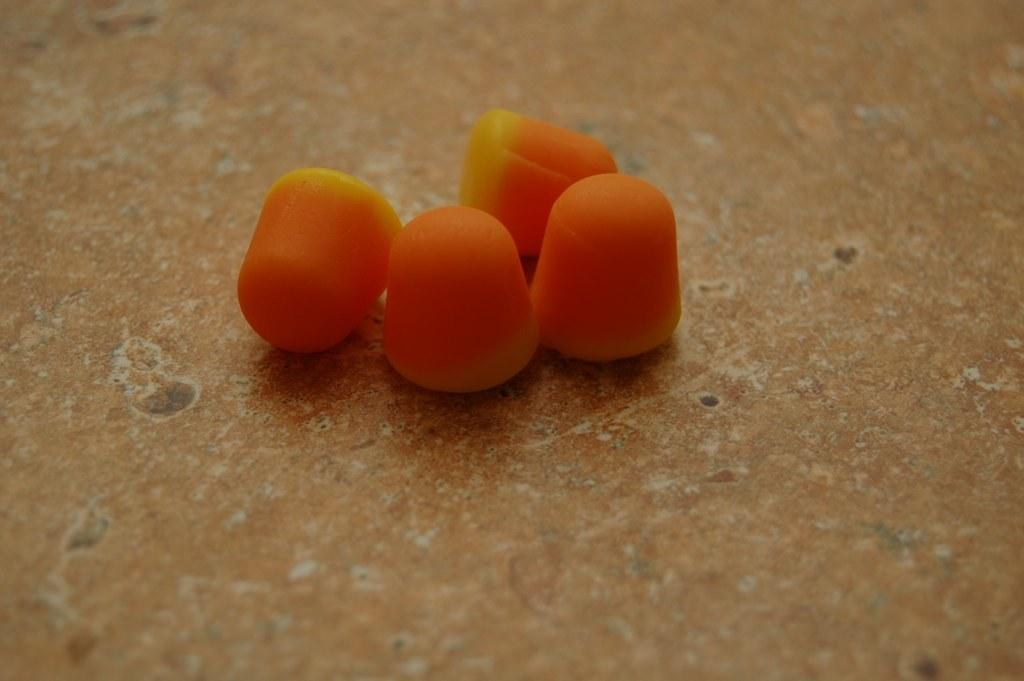What is on the floor in the image? There are fruits on the floor in the image. Can you describe the fruits? The provided facts do not include a description of the fruits. Are there any other objects or figures in the image besides the fruits? The provided facts do not mention any other objects or figures in the image. How many cats are playing with the scissors in the image? There are no cats or scissors present in the image; it only features fruits on the floor. 